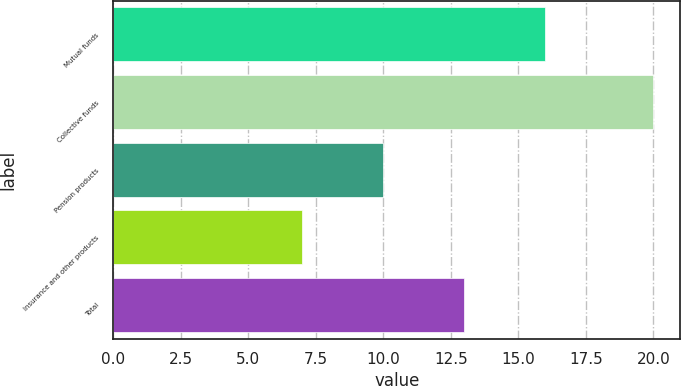Convert chart. <chart><loc_0><loc_0><loc_500><loc_500><bar_chart><fcel>Mutual funds<fcel>Collective funds<fcel>Pension products<fcel>Insurance and other products<fcel>Total<nl><fcel>16<fcel>20<fcel>10<fcel>7<fcel>13<nl></chart> 